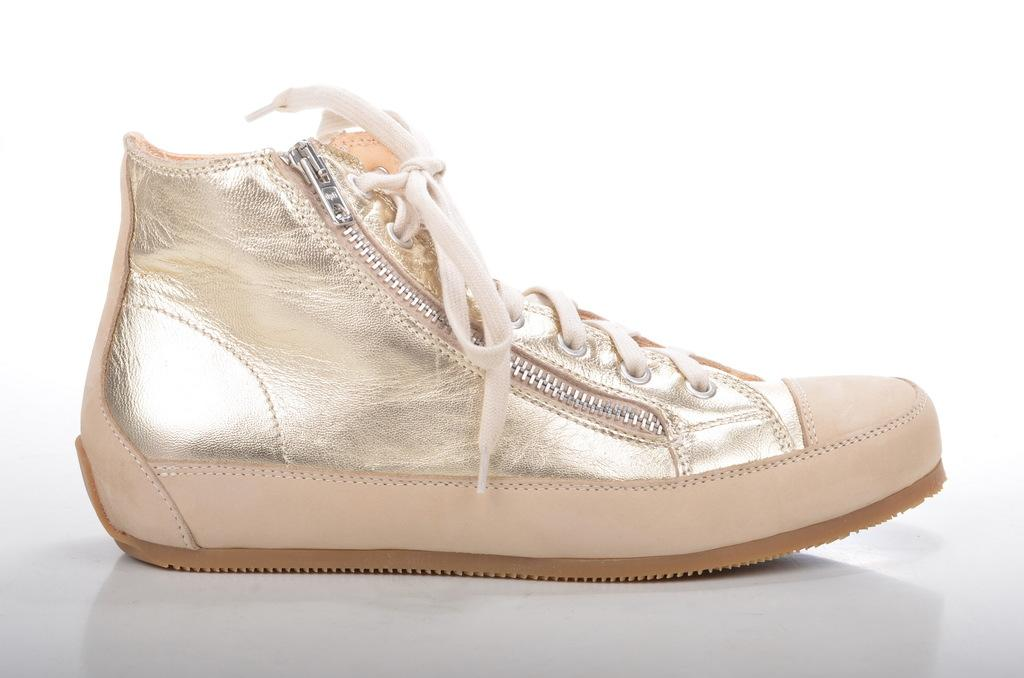What object can be seen in the image? There is a shoe in the image. What type of nut is being used to secure the shoe in the image? There is no nut present in the image; it is a shoe without any visible fasteners. 